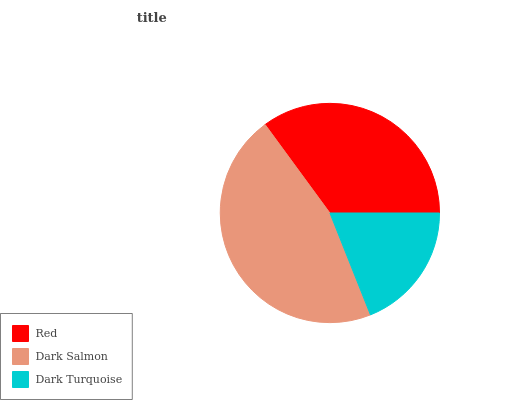Is Dark Turquoise the minimum?
Answer yes or no. Yes. Is Dark Salmon the maximum?
Answer yes or no. Yes. Is Dark Salmon the minimum?
Answer yes or no. No. Is Dark Turquoise the maximum?
Answer yes or no. No. Is Dark Salmon greater than Dark Turquoise?
Answer yes or no. Yes. Is Dark Turquoise less than Dark Salmon?
Answer yes or no. Yes. Is Dark Turquoise greater than Dark Salmon?
Answer yes or no. No. Is Dark Salmon less than Dark Turquoise?
Answer yes or no. No. Is Red the high median?
Answer yes or no. Yes. Is Red the low median?
Answer yes or no. Yes. Is Dark Salmon the high median?
Answer yes or no. No. Is Dark Salmon the low median?
Answer yes or no. No. 